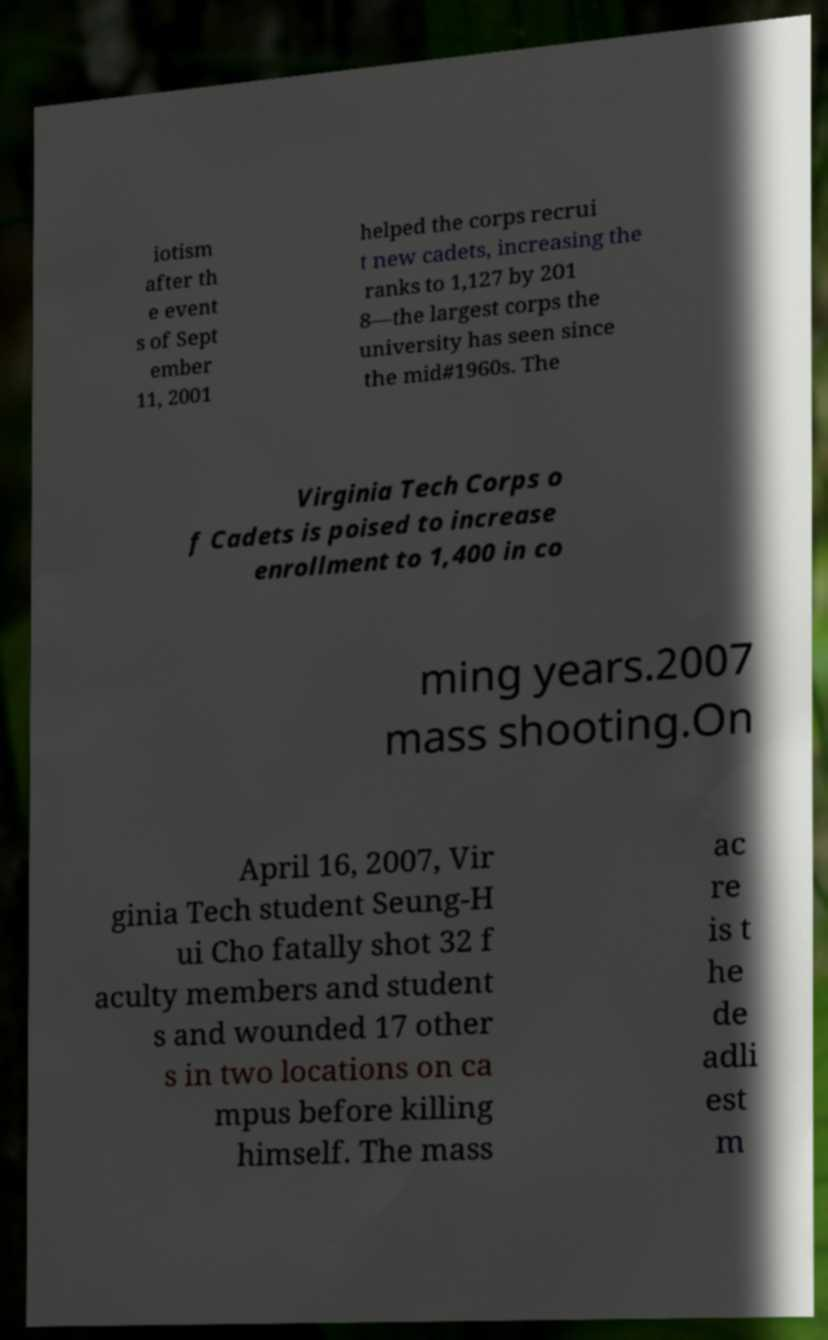What messages or text are displayed in this image? I need them in a readable, typed format. iotism after th e event s of Sept ember 11, 2001 helped the corps recrui t new cadets, increasing the ranks to 1,127 by 201 8—the largest corps the university has seen since the mid#1960s. The Virginia Tech Corps o f Cadets is poised to increase enrollment to 1,400 in co ming years.2007 mass shooting.On April 16, 2007, Vir ginia Tech student Seung-H ui Cho fatally shot 32 f aculty members and student s and wounded 17 other s in two locations on ca mpus before killing himself. The mass ac re is t he de adli est m 